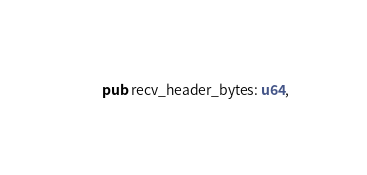<code> <loc_0><loc_0><loc_500><loc_500><_Rust_>    pub recv_header_bytes: u64,</code> 